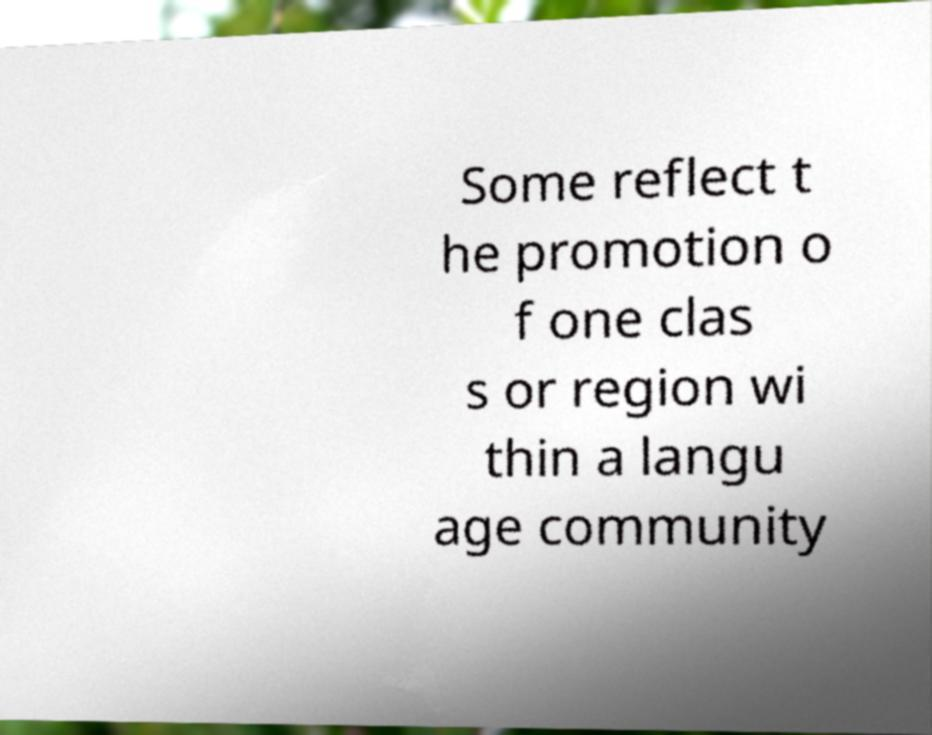For documentation purposes, I need the text within this image transcribed. Could you provide that? Some reflect t he promotion o f one clas s or region wi thin a langu age community 